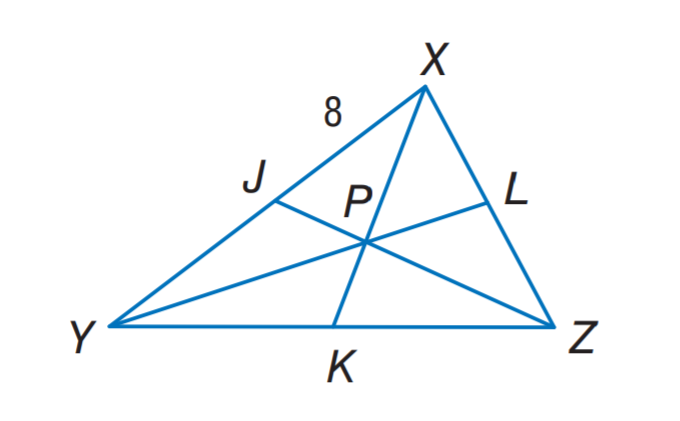Answer the mathemtical geometry problem and directly provide the correct option letter.
Question: in \triangle X Y Z, P is the centroid, K P = 3, and X J = 8. Find X K.
Choices: A: 3 B: 6 C: 8 D: 9 D 